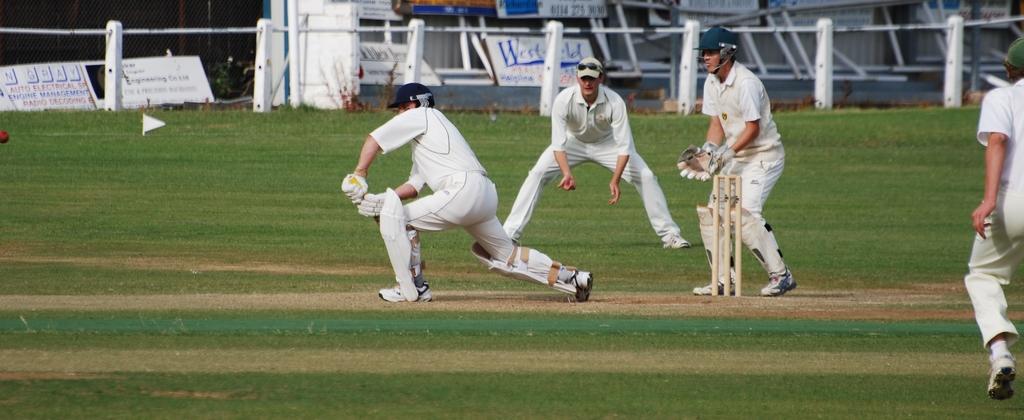How would you summarize this image in a sentence or two? In this people are playing cricket on the ground. At the back side there are metal rods. At the background there are banners. 